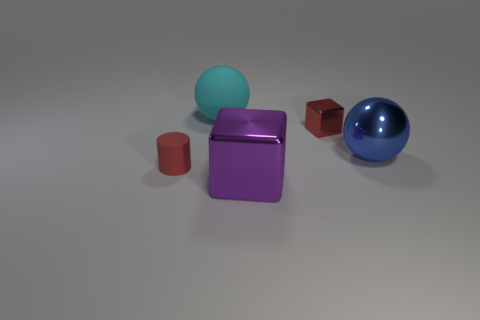Can you describe the colors of the objects? Certainly! There are five objects in the image, each with its distinct color. Starting from the left, there's a teal sphere, a purple metallic cube in the center, a small brown cylinder, a crimson small cube, and finally, a large blue metallic sphere to the right. 